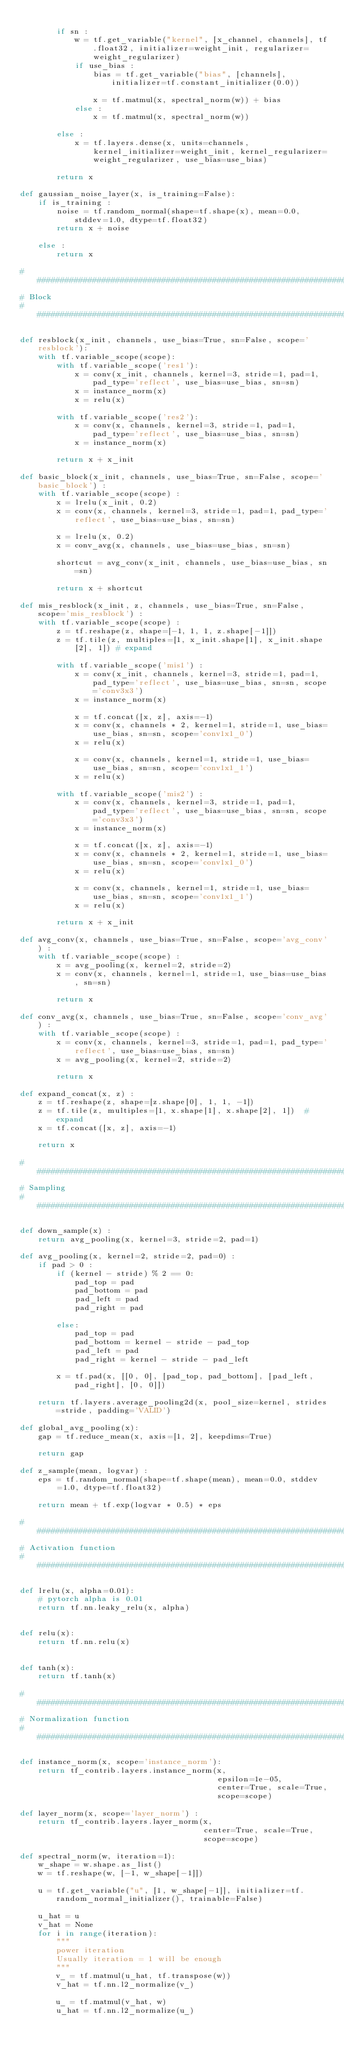Convert code to text. <code><loc_0><loc_0><loc_500><loc_500><_Python_>
        if sn :
            w = tf.get_variable("kernel", [x_channel, channels], tf.float32, initializer=weight_init, regularizer=weight_regularizer)
            if use_bias :
                bias = tf.get_variable("bias", [channels], initializer=tf.constant_initializer(0.0))

                x = tf.matmul(x, spectral_norm(w)) + bias
            else :
                x = tf.matmul(x, spectral_norm(w))

        else :
            x = tf.layers.dense(x, units=channels, kernel_initializer=weight_init, kernel_regularizer=weight_regularizer, use_bias=use_bias)

        return x

def gaussian_noise_layer(x, is_training=False):
    if is_training :
        noise = tf.random_normal(shape=tf.shape(x), mean=0.0, stddev=1.0, dtype=tf.float32)
        return x + noise

    else :
        return x

##################################################################################
# Block
##################################################################################

def resblock(x_init, channels, use_bias=True, sn=False, scope='resblock'):
    with tf.variable_scope(scope):
        with tf.variable_scope('res1'):
            x = conv(x_init, channels, kernel=3, stride=1, pad=1, pad_type='reflect', use_bias=use_bias, sn=sn)
            x = instance_norm(x)
            x = relu(x)

        with tf.variable_scope('res2'):
            x = conv(x, channels, kernel=3, stride=1, pad=1, pad_type='reflect', use_bias=use_bias, sn=sn)
            x = instance_norm(x)

        return x + x_init

def basic_block(x_init, channels, use_bias=True, sn=False, scope='basic_block') :
    with tf.variable_scope(scope) :
        x = lrelu(x_init, 0.2)
        x = conv(x, channels, kernel=3, stride=1, pad=1, pad_type='reflect', use_bias=use_bias, sn=sn)

        x = lrelu(x, 0.2)
        x = conv_avg(x, channels, use_bias=use_bias, sn=sn)

        shortcut = avg_conv(x_init, channels, use_bias=use_bias, sn=sn)

        return x + shortcut

def mis_resblock(x_init, z, channels, use_bias=True, sn=False, scope='mis_resblock') :
    with tf.variable_scope(scope) :
        z = tf.reshape(z, shape=[-1, 1, 1, z.shape[-1]])
        z = tf.tile(z, multiples=[1, x_init.shape[1], x_init.shape[2], 1]) # expand

        with tf.variable_scope('mis1') :
            x = conv(x_init, channels, kernel=3, stride=1, pad=1, pad_type='reflect', use_bias=use_bias, sn=sn, scope='conv3x3')
            x = instance_norm(x)

            x = tf.concat([x, z], axis=-1)
            x = conv(x, channels * 2, kernel=1, stride=1, use_bias=use_bias, sn=sn, scope='conv1x1_0')
            x = relu(x)

            x = conv(x, channels, kernel=1, stride=1, use_bias=use_bias, sn=sn, scope='conv1x1_1')
            x = relu(x)

        with tf.variable_scope('mis2') :
            x = conv(x, channels, kernel=3, stride=1, pad=1, pad_type='reflect', use_bias=use_bias, sn=sn, scope='conv3x3')
            x = instance_norm(x)

            x = tf.concat([x, z], axis=-1)
            x = conv(x, channels * 2, kernel=1, stride=1, use_bias=use_bias, sn=sn, scope='conv1x1_0')
            x = relu(x)

            x = conv(x, channels, kernel=1, stride=1, use_bias=use_bias, sn=sn, scope='conv1x1_1')
            x = relu(x)

        return x + x_init

def avg_conv(x, channels, use_bias=True, sn=False, scope='avg_conv') :
    with tf.variable_scope(scope) :
        x = avg_pooling(x, kernel=2, stride=2)
        x = conv(x, channels, kernel=1, stride=1, use_bias=use_bias, sn=sn)

        return x

def conv_avg(x, channels, use_bias=True, sn=False, scope='conv_avg') :
    with tf.variable_scope(scope) :
        x = conv(x, channels, kernel=3, stride=1, pad=1, pad_type='reflect', use_bias=use_bias, sn=sn)
        x = avg_pooling(x, kernel=2, stride=2)

        return x

def expand_concat(x, z) :
    z = tf.reshape(z, shape=[z.shape[0], 1, 1, -1])
    z = tf.tile(z, multiples=[1, x.shape[1], x.shape[2], 1])  # expand
    x = tf.concat([x, z], axis=-1)

    return x

##################################################################################
# Sampling
##################################################################################

def down_sample(x) :
    return avg_pooling(x, kernel=3, stride=2, pad=1)

def avg_pooling(x, kernel=2, stride=2, pad=0) :
    if pad > 0 :
        if (kernel - stride) % 2 == 0:
            pad_top = pad
            pad_bottom = pad
            pad_left = pad
            pad_right = pad

        else:
            pad_top = pad
            pad_bottom = kernel - stride - pad_top
            pad_left = pad
            pad_right = kernel - stride - pad_left

        x = tf.pad(x, [[0, 0], [pad_top, pad_bottom], [pad_left, pad_right], [0, 0]])

    return tf.layers.average_pooling2d(x, pool_size=kernel, strides=stride, padding='VALID')

def global_avg_pooling(x):
    gap = tf.reduce_mean(x, axis=[1, 2], keepdims=True)

    return gap

def z_sample(mean, logvar) :
    eps = tf.random_normal(shape=tf.shape(mean), mean=0.0, stddev=1.0, dtype=tf.float32)

    return mean + tf.exp(logvar * 0.5) * eps

##################################################################################
# Activation function
##################################################################################

def lrelu(x, alpha=0.01):
    # pytorch alpha is 0.01
    return tf.nn.leaky_relu(x, alpha)


def relu(x):
    return tf.nn.relu(x)


def tanh(x):
    return tf.tanh(x)

##################################################################################
# Normalization function
##################################################################################

def instance_norm(x, scope='instance_norm'):
    return tf_contrib.layers.instance_norm(x,
                                           epsilon=1e-05,
                                           center=True, scale=True,
                                           scope=scope)

def layer_norm(x, scope='layer_norm') :
    return tf_contrib.layers.layer_norm(x,
                                        center=True, scale=True,
                                        scope=scope)

def spectral_norm(w, iteration=1):
    w_shape = w.shape.as_list()
    w = tf.reshape(w, [-1, w_shape[-1]])

    u = tf.get_variable("u", [1, w_shape[-1]], initializer=tf.random_normal_initializer(), trainable=False)

    u_hat = u
    v_hat = None
    for i in range(iteration):
        """
        power iteration
        Usually iteration = 1 will be enough
        """
        v_ = tf.matmul(u_hat, tf.transpose(w))
        v_hat = tf.nn.l2_normalize(v_)

        u_ = tf.matmul(v_hat, w)
        u_hat = tf.nn.l2_normalize(u_)
</code> 